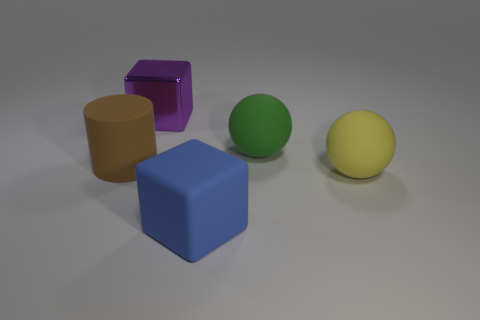Add 3 large brown spheres. How many objects exist? 8 Subtract all cylinders. How many objects are left? 4 Subtract all matte things. Subtract all small red metallic things. How many objects are left? 1 Add 3 rubber spheres. How many rubber spheres are left? 5 Add 5 blue cubes. How many blue cubes exist? 6 Subtract 0 blue balls. How many objects are left? 5 